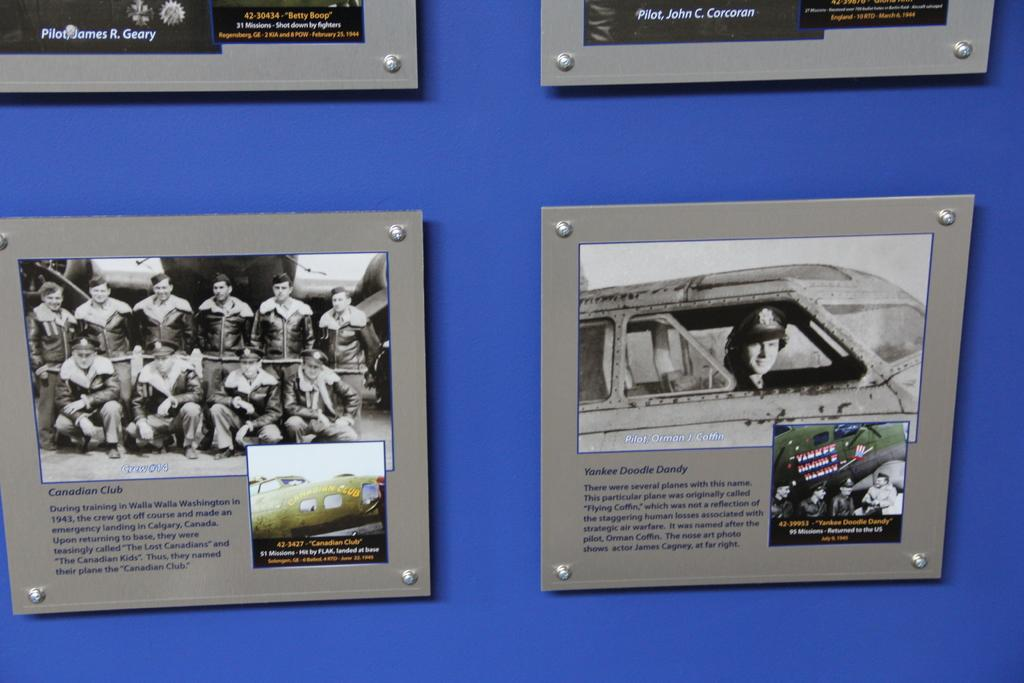What color is the wall in the image? There is a blue wall in the image. What is attached to the wall? There are boards on the wall. What can be seen on the boards? There is writing and pictures of people on the boards. Are there any cherries growing on the wall in the image? There are no cherries present in the image. What type of farm can be seen in the background of the image? There is no farm visible in the image; it only shows a blue wall with boards on it. 